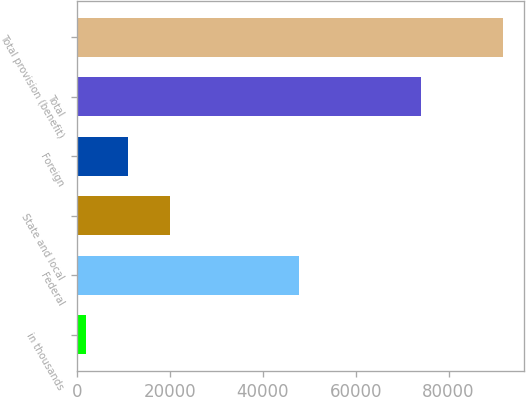Convert chart to OTSL. <chart><loc_0><loc_0><loc_500><loc_500><bar_chart><fcel>in thousands<fcel>Federal<fcel>State and local<fcel>Foreign<fcel>Total<fcel>Total provision (benefit)<nl><fcel>2014<fcel>47882<fcel>19949.6<fcel>10981.8<fcel>74039<fcel>91692<nl></chart> 